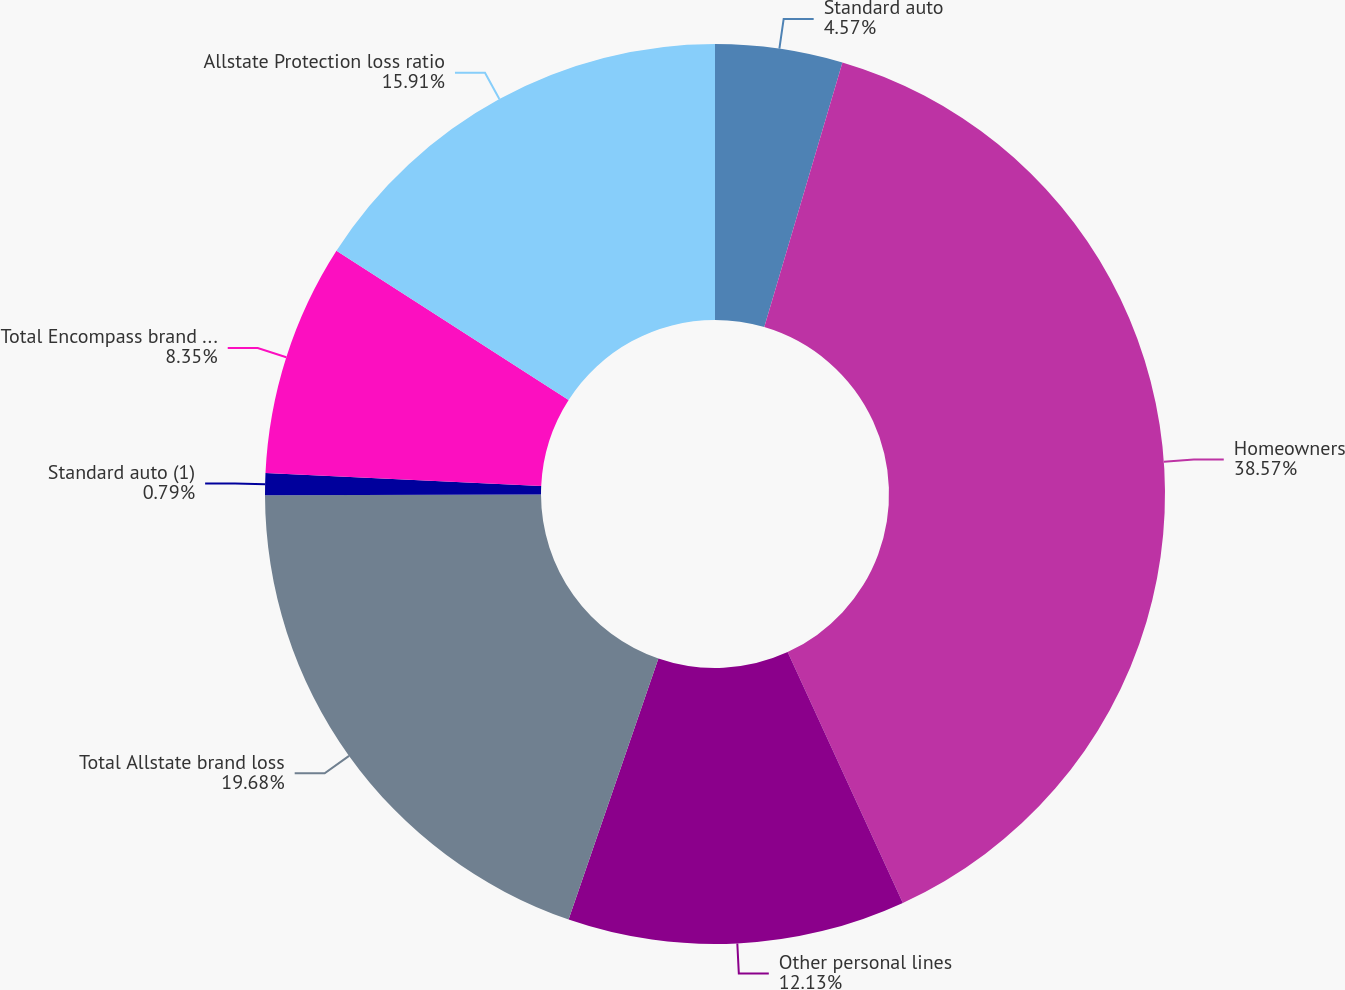Convert chart. <chart><loc_0><loc_0><loc_500><loc_500><pie_chart><fcel>Standard auto<fcel>Homeowners<fcel>Other personal lines<fcel>Total Allstate brand loss<fcel>Standard auto (1)<fcel>Total Encompass brand loss<fcel>Allstate Protection loss ratio<nl><fcel>4.57%<fcel>38.58%<fcel>12.13%<fcel>19.68%<fcel>0.79%<fcel>8.35%<fcel>15.91%<nl></chart> 